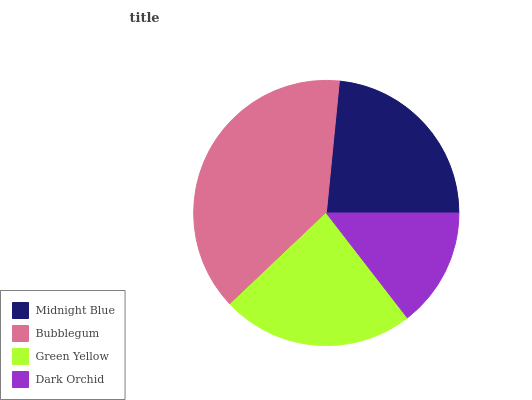Is Dark Orchid the minimum?
Answer yes or no. Yes. Is Bubblegum the maximum?
Answer yes or no. Yes. Is Green Yellow the minimum?
Answer yes or no. No. Is Green Yellow the maximum?
Answer yes or no. No. Is Bubblegum greater than Green Yellow?
Answer yes or no. Yes. Is Green Yellow less than Bubblegum?
Answer yes or no. Yes. Is Green Yellow greater than Bubblegum?
Answer yes or no. No. Is Bubblegum less than Green Yellow?
Answer yes or no. No. Is Midnight Blue the high median?
Answer yes or no. Yes. Is Green Yellow the low median?
Answer yes or no. Yes. Is Dark Orchid the high median?
Answer yes or no. No. Is Dark Orchid the low median?
Answer yes or no. No. 